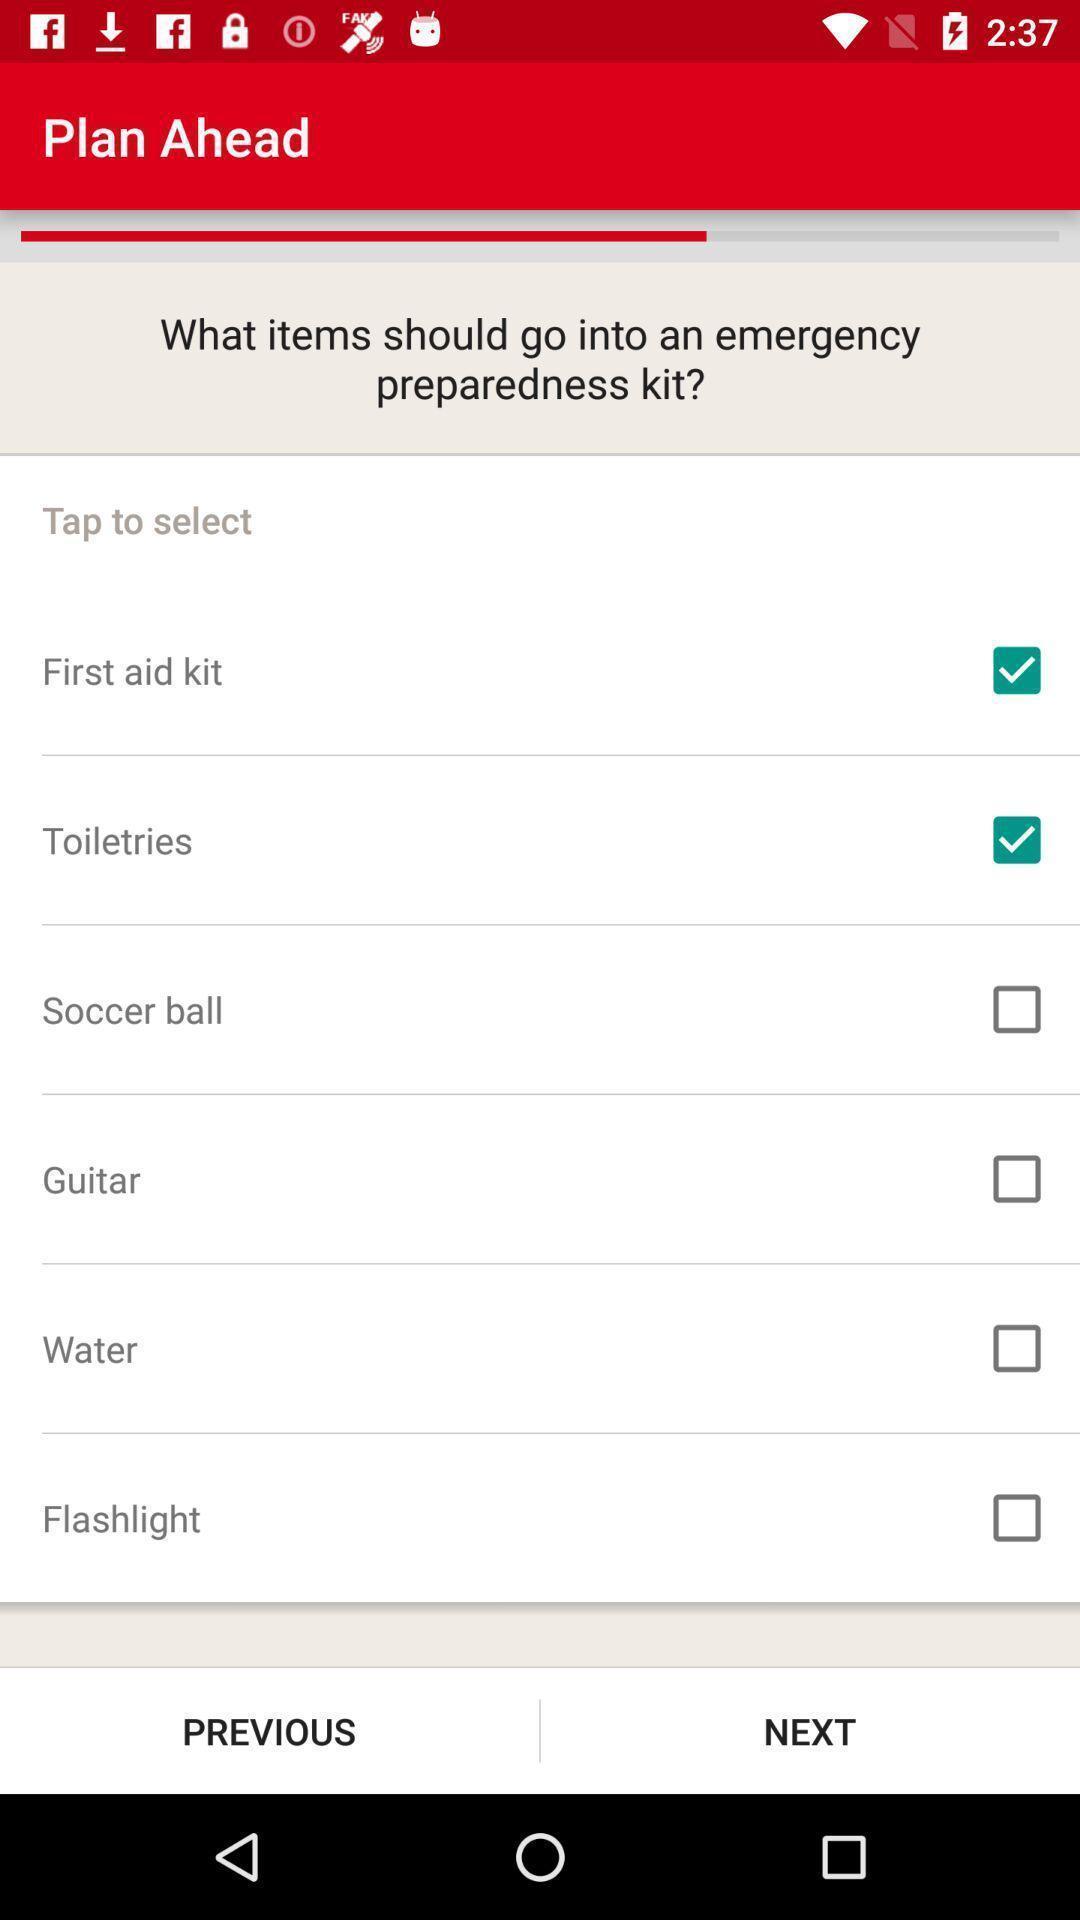Explain the elements present in this screenshot. Page showing information about application. 